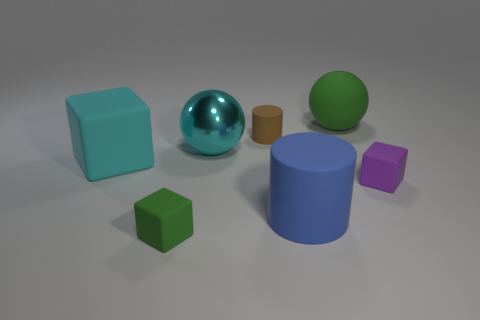Add 2 large blue things. How many objects exist? 9 Subtract all cylinders. How many objects are left? 5 Subtract all big red cylinders. Subtract all small brown things. How many objects are left? 6 Add 1 big green rubber balls. How many big green rubber balls are left? 2 Add 4 large cyan balls. How many large cyan balls exist? 5 Subtract 1 cyan spheres. How many objects are left? 6 